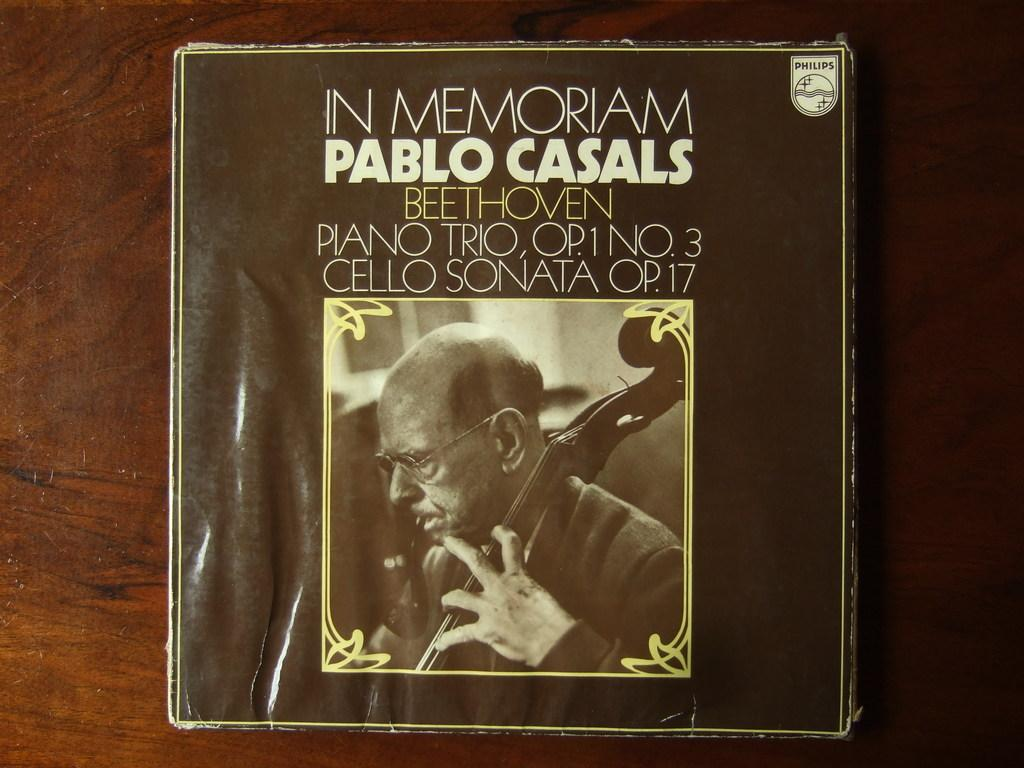<image>
Share a concise interpretation of the image provided. A cover of In Memoriam Pablo Casals Beethoven. 